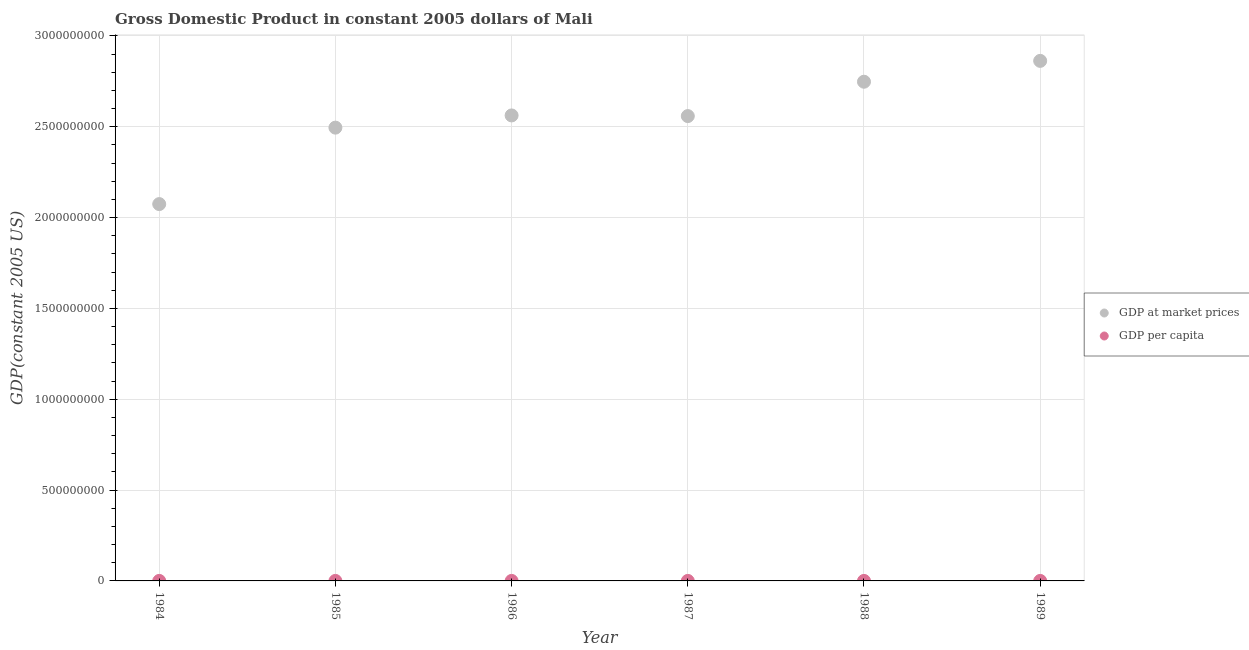What is the gdp per capita in 1985?
Keep it short and to the point. 318.61. Across all years, what is the maximum gdp per capita?
Offer a very short reply. 343.98. Across all years, what is the minimum gdp per capita?
Keep it short and to the point. 269.68. What is the total gdp per capita in the graph?
Offer a very short reply. 1906.82. What is the difference between the gdp at market prices in 1986 and that in 1989?
Provide a short and direct response. -3.00e+08. What is the difference between the gdp per capita in 1985 and the gdp at market prices in 1987?
Your response must be concise. -2.56e+09. What is the average gdp at market prices per year?
Offer a terse response. 2.55e+09. In the year 1985, what is the difference between the gdp at market prices and gdp per capita?
Make the answer very short. 2.50e+09. What is the ratio of the gdp at market prices in 1985 to that in 1989?
Keep it short and to the point. 0.87. Is the gdp at market prices in 1984 less than that in 1987?
Provide a succinct answer. Yes. What is the difference between the highest and the second highest gdp at market prices?
Give a very brief answer. 1.15e+08. What is the difference between the highest and the lowest gdp per capita?
Your answer should be very brief. 74.31. Is the gdp per capita strictly greater than the gdp at market prices over the years?
Keep it short and to the point. No. How many years are there in the graph?
Give a very brief answer. 6. Does the graph contain any zero values?
Make the answer very short. No. Does the graph contain grids?
Your answer should be very brief. Yes. How are the legend labels stacked?
Your answer should be very brief. Vertical. What is the title of the graph?
Offer a very short reply. Gross Domestic Product in constant 2005 dollars of Mali. What is the label or title of the Y-axis?
Your response must be concise. GDP(constant 2005 US). What is the GDP(constant 2005 US) in GDP at market prices in 1984?
Keep it short and to the point. 2.07e+09. What is the GDP(constant 2005 US) of GDP per capita in 1984?
Make the answer very short. 269.68. What is the GDP(constant 2005 US) in GDP at market prices in 1985?
Provide a succinct answer. 2.50e+09. What is the GDP(constant 2005 US) in GDP per capita in 1985?
Your answer should be compact. 318.61. What is the GDP(constant 2005 US) in GDP at market prices in 1986?
Keep it short and to the point. 2.56e+09. What is the GDP(constant 2005 US) of GDP per capita in 1986?
Ensure brevity in your answer.  322.03. What is the GDP(constant 2005 US) of GDP at market prices in 1987?
Make the answer very short. 2.56e+09. What is the GDP(constant 2005 US) in GDP per capita in 1987?
Make the answer very short. 316.97. What is the GDP(constant 2005 US) of GDP at market prices in 1988?
Ensure brevity in your answer.  2.75e+09. What is the GDP(constant 2005 US) of GDP per capita in 1988?
Provide a short and direct response. 335.54. What is the GDP(constant 2005 US) of GDP at market prices in 1989?
Your answer should be very brief. 2.86e+09. What is the GDP(constant 2005 US) in GDP per capita in 1989?
Offer a terse response. 343.98. Across all years, what is the maximum GDP(constant 2005 US) in GDP at market prices?
Ensure brevity in your answer.  2.86e+09. Across all years, what is the maximum GDP(constant 2005 US) in GDP per capita?
Give a very brief answer. 343.98. Across all years, what is the minimum GDP(constant 2005 US) in GDP at market prices?
Provide a succinct answer. 2.07e+09. Across all years, what is the minimum GDP(constant 2005 US) in GDP per capita?
Your answer should be very brief. 269.68. What is the total GDP(constant 2005 US) in GDP at market prices in the graph?
Make the answer very short. 1.53e+1. What is the total GDP(constant 2005 US) in GDP per capita in the graph?
Ensure brevity in your answer.  1906.82. What is the difference between the GDP(constant 2005 US) of GDP at market prices in 1984 and that in 1985?
Your answer should be very brief. -4.21e+08. What is the difference between the GDP(constant 2005 US) of GDP per capita in 1984 and that in 1985?
Your answer should be very brief. -48.94. What is the difference between the GDP(constant 2005 US) of GDP at market prices in 1984 and that in 1986?
Ensure brevity in your answer.  -4.88e+08. What is the difference between the GDP(constant 2005 US) in GDP per capita in 1984 and that in 1986?
Your answer should be compact. -52.36. What is the difference between the GDP(constant 2005 US) in GDP at market prices in 1984 and that in 1987?
Your answer should be compact. -4.84e+08. What is the difference between the GDP(constant 2005 US) in GDP per capita in 1984 and that in 1987?
Offer a very short reply. -47.29. What is the difference between the GDP(constant 2005 US) in GDP at market prices in 1984 and that in 1988?
Your answer should be compact. -6.74e+08. What is the difference between the GDP(constant 2005 US) of GDP per capita in 1984 and that in 1988?
Your answer should be very brief. -65.86. What is the difference between the GDP(constant 2005 US) of GDP at market prices in 1984 and that in 1989?
Ensure brevity in your answer.  -7.88e+08. What is the difference between the GDP(constant 2005 US) in GDP per capita in 1984 and that in 1989?
Keep it short and to the point. -74.31. What is the difference between the GDP(constant 2005 US) of GDP at market prices in 1985 and that in 1986?
Your response must be concise. -6.72e+07. What is the difference between the GDP(constant 2005 US) in GDP per capita in 1985 and that in 1986?
Provide a succinct answer. -3.42. What is the difference between the GDP(constant 2005 US) of GDP at market prices in 1985 and that in 1987?
Provide a succinct answer. -6.36e+07. What is the difference between the GDP(constant 2005 US) of GDP per capita in 1985 and that in 1987?
Ensure brevity in your answer.  1.64. What is the difference between the GDP(constant 2005 US) of GDP at market prices in 1985 and that in 1988?
Keep it short and to the point. -2.53e+08. What is the difference between the GDP(constant 2005 US) in GDP per capita in 1985 and that in 1988?
Give a very brief answer. -16.93. What is the difference between the GDP(constant 2005 US) in GDP at market prices in 1985 and that in 1989?
Your answer should be very brief. -3.68e+08. What is the difference between the GDP(constant 2005 US) in GDP per capita in 1985 and that in 1989?
Your answer should be very brief. -25.37. What is the difference between the GDP(constant 2005 US) in GDP at market prices in 1986 and that in 1987?
Give a very brief answer. 3.57e+06. What is the difference between the GDP(constant 2005 US) of GDP per capita in 1986 and that in 1987?
Your answer should be compact. 5.06. What is the difference between the GDP(constant 2005 US) of GDP at market prices in 1986 and that in 1988?
Ensure brevity in your answer.  -1.86e+08. What is the difference between the GDP(constant 2005 US) of GDP per capita in 1986 and that in 1988?
Your answer should be compact. -13.51. What is the difference between the GDP(constant 2005 US) of GDP at market prices in 1986 and that in 1989?
Provide a short and direct response. -3.00e+08. What is the difference between the GDP(constant 2005 US) in GDP per capita in 1986 and that in 1989?
Provide a succinct answer. -21.95. What is the difference between the GDP(constant 2005 US) of GDP at market prices in 1987 and that in 1988?
Provide a succinct answer. -1.89e+08. What is the difference between the GDP(constant 2005 US) in GDP per capita in 1987 and that in 1988?
Your response must be concise. -18.57. What is the difference between the GDP(constant 2005 US) of GDP at market prices in 1987 and that in 1989?
Your answer should be very brief. -3.04e+08. What is the difference between the GDP(constant 2005 US) of GDP per capita in 1987 and that in 1989?
Your response must be concise. -27.01. What is the difference between the GDP(constant 2005 US) in GDP at market prices in 1988 and that in 1989?
Provide a short and direct response. -1.15e+08. What is the difference between the GDP(constant 2005 US) of GDP per capita in 1988 and that in 1989?
Your response must be concise. -8.44. What is the difference between the GDP(constant 2005 US) in GDP at market prices in 1984 and the GDP(constant 2005 US) in GDP per capita in 1985?
Your response must be concise. 2.07e+09. What is the difference between the GDP(constant 2005 US) of GDP at market prices in 1984 and the GDP(constant 2005 US) of GDP per capita in 1986?
Provide a succinct answer. 2.07e+09. What is the difference between the GDP(constant 2005 US) in GDP at market prices in 1984 and the GDP(constant 2005 US) in GDP per capita in 1987?
Ensure brevity in your answer.  2.07e+09. What is the difference between the GDP(constant 2005 US) in GDP at market prices in 1984 and the GDP(constant 2005 US) in GDP per capita in 1988?
Your answer should be compact. 2.07e+09. What is the difference between the GDP(constant 2005 US) of GDP at market prices in 1984 and the GDP(constant 2005 US) of GDP per capita in 1989?
Your answer should be very brief. 2.07e+09. What is the difference between the GDP(constant 2005 US) in GDP at market prices in 1985 and the GDP(constant 2005 US) in GDP per capita in 1986?
Offer a very short reply. 2.50e+09. What is the difference between the GDP(constant 2005 US) in GDP at market prices in 1985 and the GDP(constant 2005 US) in GDP per capita in 1987?
Offer a very short reply. 2.50e+09. What is the difference between the GDP(constant 2005 US) of GDP at market prices in 1985 and the GDP(constant 2005 US) of GDP per capita in 1988?
Make the answer very short. 2.50e+09. What is the difference between the GDP(constant 2005 US) in GDP at market prices in 1985 and the GDP(constant 2005 US) in GDP per capita in 1989?
Make the answer very short. 2.50e+09. What is the difference between the GDP(constant 2005 US) in GDP at market prices in 1986 and the GDP(constant 2005 US) in GDP per capita in 1987?
Give a very brief answer. 2.56e+09. What is the difference between the GDP(constant 2005 US) of GDP at market prices in 1986 and the GDP(constant 2005 US) of GDP per capita in 1988?
Offer a terse response. 2.56e+09. What is the difference between the GDP(constant 2005 US) in GDP at market prices in 1986 and the GDP(constant 2005 US) in GDP per capita in 1989?
Keep it short and to the point. 2.56e+09. What is the difference between the GDP(constant 2005 US) in GDP at market prices in 1987 and the GDP(constant 2005 US) in GDP per capita in 1988?
Provide a succinct answer. 2.56e+09. What is the difference between the GDP(constant 2005 US) of GDP at market prices in 1987 and the GDP(constant 2005 US) of GDP per capita in 1989?
Give a very brief answer. 2.56e+09. What is the difference between the GDP(constant 2005 US) of GDP at market prices in 1988 and the GDP(constant 2005 US) of GDP per capita in 1989?
Your response must be concise. 2.75e+09. What is the average GDP(constant 2005 US) of GDP at market prices per year?
Your answer should be compact. 2.55e+09. What is the average GDP(constant 2005 US) of GDP per capita per year?
Provide a short and direct response. 317.8. In the year 1984, what is the difference between the GDP(constant 2005 US) of GDP at market prices and GDP(constant 2005 US) of GDP per capita?
Provide a short and direct response. 2.07e+09. In the year 1985, what is the difference between the GDP(constant 2005 US) of GDP at market prices and GDP(constant 2005 US) of GDP per capita?
Your answer should be very brief. 2.50e+09. In the year 1986, what is the difference between the GDP(constant 2005 US) of GDP at market prices and GDP(constant 2005 US) of GDP per capita?
Provide a short and direct response. 2.56e+09. In the year 1987, what is the difference between the GDP(constant 2005 US) of GDP at market prices and GDP(constant 2005 US) of GDP per capita?
Ensure brevity in your answer.  2.56e+09. In the year 1988, what is the difference between the GDP(constant 2005 US) of GDP at market prices and GDP(constant 2005 US) of GDP per capita?
Keep it short and to the point. 2.75e+09. In the year 1989, what is the difference between the GDP(constant 2005 US) in GDP at market prices and GDP(constant 2005 US) in GDP per capita?
Make the answer very short. 2.86e+09. What is the ratio of the GDP(constant 2005 US) of GDP at market prices in 1984 to that in 1985?
Your answer should be very brief. 0.83. What is the ratio of the GDP(constant 2005 US) of GDP per capita in 1984 to that in 1985?
Your answer should be compact. 0.85. What is the ratio of the GDP(constant 2005 US) of GDP at market prices in 1984 to that in 1986?
Provide a short and direct response. 0.81. What is the ratio of the GDP(constant 2005 US) in GDP per capita in 1984 to that in 1986?
Keep it short and to the point. 0.84. What is the ratio of the GDP(constant 2005 US) of GDP at market prices in 1984 to that in 1987?
Offer a terse response. 0.81. What is the ratio of the GDP(constant 2005 US) of GDP per capita in 1984 to that in 1987?
Your response must be concise. 0.85. What is the ratio of the GDP(constant 2005 US) in GDP at market prices in 1984 to that in 1988?
Make the answer very short. 0.75. What is the ratio of the GDP(constant 2005 US) of GDP per capita in 1984 to that in 1988?
Provide a short and direct response. 0.8. What is the ratio of the GDP(constant 2005 US) in GDP at market prices in 1984 to that in 1989?
Your answer should be compact. 0.72. What is the ratio of the GDP(constant 2005 US) in GDP per capita in 1984 to that in 1989?
Provide a succinct answer. 0.78. What is the ratio of the GDP(constant 2005 US) in GDP at market prices in 1985 to that in 1986?
Provide a succinct answer. 0.97. What is the ratio of the GDP(constant 2005 US) of GDP at market prices in 1985 to that in 1987?
Provide a succinct answer. 0.98. What is the ratio of the GDP(constant 2005 US) in GDP at market prices in 1985 to that in 1988?
Offer a terse response. 0.91. What is the ratio of the GDP(constant 2005 US) of GDP per capita in 1985 to that in 1988?
Ensure brevity in your answer.  0.95. What is the ratio of the GDP(constant 2005 US) of GDP at market prices in 1985 to that in 1989?
Provide a short and direct response. 0.87. What is the ratio of the GDP(constant 2005 US) in GDP per capita in 1985 to that in 1989?
Offer a very short reply. 0.93. What is the ratio of the GDP(constant 2005 US) of GDP per capita in 1986 to that in 1987?
Keep it short and to the point. 1.02. What is the ratio of the GDP(constant 2005 US) of GDP at market prices in 1986 to that in 1988?
Ensure brevity in your answer.  0.93. What is the ratio of the GDP(constant 2005 US) of GDP per capita in 1986 to that in 1988?
Your response must be concise. 0.96. What is the ratio of the GDP(constant 2005 US) in GDP at market prices in 1986 to that in 1989?
Keep it short and to the point. 0.9. What is the ratio of the GDP(constant 2005 US) of GDP per capita in 1986 to that in 1989?
Provide a short and direct response. 0.94. What is the ratio of the GDP(constant 2005 US) of GDP at market prices in 1987 to that in 1988?
Give a very brief answer. 0.93. What is the ratio of the GDP(constant 2005 US) in GDP per capita in 1987 to that in 1988?
Your response must be concise. 0.94. What is the ratio of the GDP(constant 2005 US) in GDP at market prices in 1987 to that in 1989?
Your answer should be compact. 0.89. What is the ratio of the GDP(constant 2005 US) of GDP per capita in 1987 to that in 1989?
Your answer should be very brief. 0.92. What is the ratio of the GDP(constant 2005 US) in GDP at market prices in 1988 to that in 1989?
Offer a terse response. 0.96. What is the ratio of the GDP(constant 2005 US) of GDP per capita in 1988 to that in 1989?
Your response must be concise. 0.98. What is the difference between the highest and the second highest GDP(constant 2005 US) of GDP at market prices?
Provide a succinct answer. 1.15e+08. What is the difference between the highest and the second highest GDP(constant 2005 US) in GDP per capita?
Provide a short and direct response. 8.44. What is the difference between the highest and the lowest GDP(constant 2005 US) in GDP at market prices?
Your answer should be compact. 7.88e+08. What is the difference between the highest and the lowest GDP(constant 2005 US) of GDP per capita?
Your answer should be very brief. 74.31. 